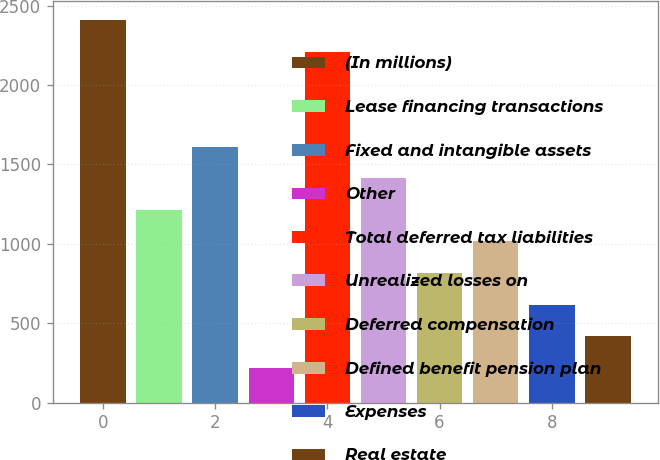Convert chart to OTSL. <chart><loc_0><loc_0><loc_500><loc_500><bar_chart><fcel>(In millions)<fcel>Lease financing transactions<fcel>Fixed and intangible assets<fcel>Other<fcel>Total deferred tax liabilities<fcel>Unrealized losses on<fcel>Deferred compensation<fcel>Defined benefit pension plan<fcel>Expenses<fcel>Real estate<nl><fcel>2409.4<fcel>1214.2<fcel>1612.6<fcel>218.2<fcel>2210.2<fcel>1413.4<fcel>815.8<fcel>1015<fcel>616.6<fcel>417.4<nl></chart> 